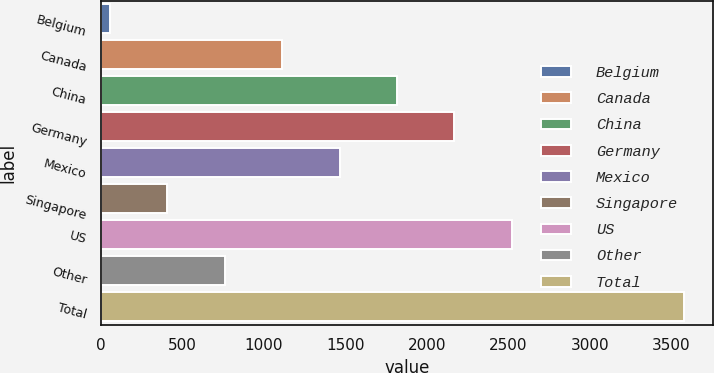Convert chart. <chart><loc_0><loc_0><loc_500><loc_500><bar_chart><fcel>Belgium<fcel>Canada<fcel>China<fcel>Germany<fcel>Mexico<fcel>Singapore<fcel>US<fcel>Other<fcel>Total<nl><fcel>55<fcel>1111.6<fcel>1816<fcel>2168.2<fcel>1463.8<fcel>407.2<fcel>2520.4<fcel>759.4<fcel>3577<nl></chart> 